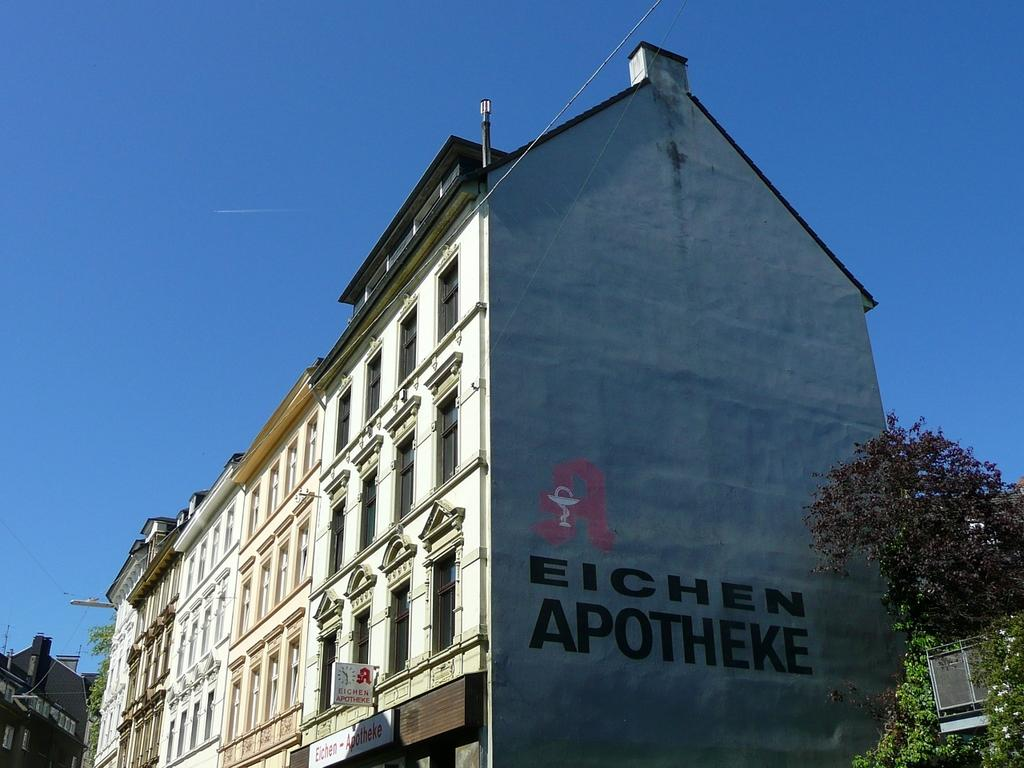What type of structure is in the image? There is a building in the image. What feature of the building is mentioned in the facts? The building has many windows. What else can be seen on the building? There is text on the side wall of the building. What natural elements are present in the image? Trees and flowers are visible in the image. What other objects can be seen in the image? Poles are in the image. What is the color of the sky in the image? The sky is blue. How many snails can be seen crawling on the building in the image? There are no snails visible in the image. What type of approval is required for the text on the side wall of the building? The facts provided do not mention any approval requirements for the text on the building. 